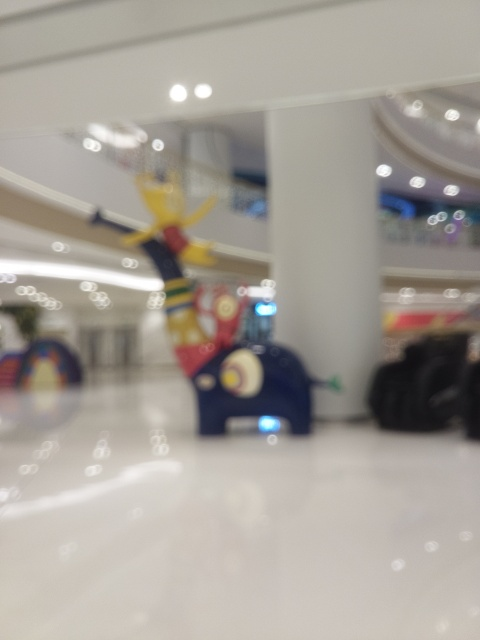Despite the image being blurry, can you make out what the central object might be? Even though the image lacks clarity, the central object appears to be a whimsical, oversized sculpture or installation. It's brightly colored with elements such as circles and what could be interpreted as limbs extending outwards, suggesting a playful theme. Such pieces are often used as focal points or photo opportunities within public spaces like malls. 